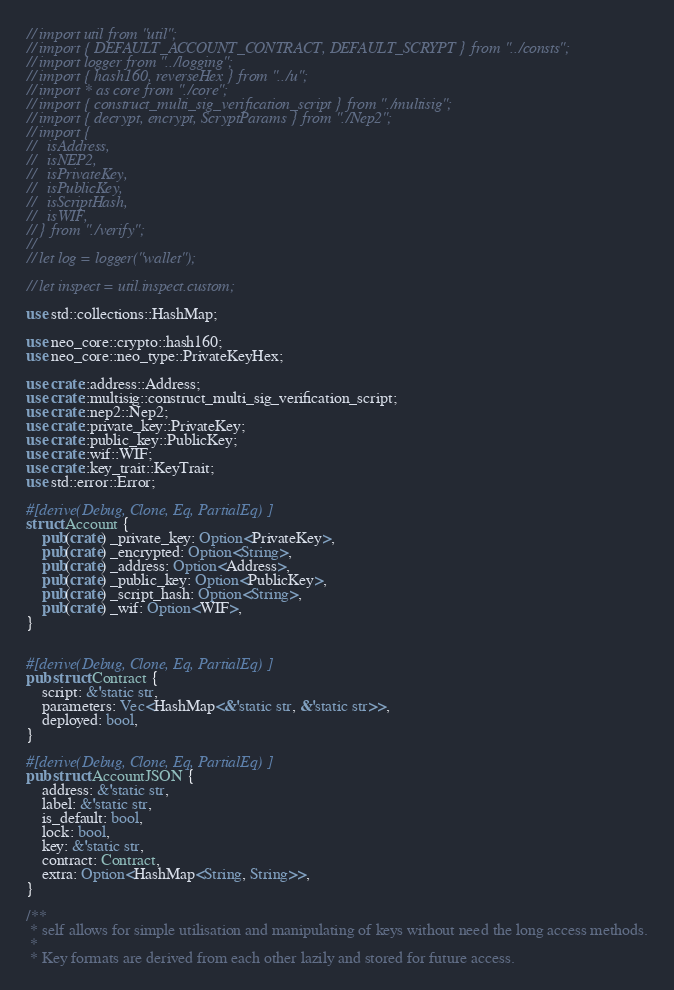<code> <loc_0><loc_0><loc_500><loc_500><_Rust_>// import util from "util";
// import { DEFAULT_ACCOUNT_CONTRACT, DEFAULT_SCRYPT } from "../consts";
// import logger from "../logging";
// import { hash160, reverseHex } from "../u";
// import * as core from "./core";
// import { construct_multi_sig_verification_script } from "./multisig";
// import { decrypt, encrypt, ScryptParams } from "./Nep2";
// import {
//   isAddress,
//   isNEP2,
//   isPrivateKey,
//   isPublicKey,
//   isScriptHash,
//   isWIF,
// } from "./verify";
//
// let log = logger("wallet");

// let inspect = util.inspect.custom;

use std::collections::HashMap;

use neo_core::crypto::hash160;
use neo_core::neo_type::PrivateKeyHex;

use crate::address::Address;
use crate::multisig::construct_multi_sig_verification_script;
use crate::nep2::Nep2;
use crate::private_key::PrivateKey;
use crate::public_key::PublicKey;
use crate::wif::WIF;
use crate::key_trait::KeyTrait;
use std::error::Error;

#[derive(Debug, Clone, Eq, PartialEq)]
struct Account {
    pub(crate) _private_key: Option<PrivateKey>,
    pub(crate) _encrypted: Option<String>,
    pub(crate) _address: Option<Address>,
    pub(crate) _public_key: Option<PublicKey>,
    pub(crate) _script_hash: Option<String>,
    pub(crate) _wif: Option<WIF>,
}


#[derive(Debug, Clone, Eq, PartialEq)]
pub struct Contract {
    script: &'static str,
    parameters: Vec<HashMap<&'static str, &'static str>>,
    deployed: bool,
}

#[derive(Debug, Clone, Eq, PartialEq)]
pub struct AccountJSON {
    address: &'static str,
    label: &'static str,
    is_default: bool,
    lock: bool,
    key: &'static str,
    contract: Contract,
    extra: Option<HashMap<String, String>>,
}

/**
 * self allows for simple utilisation and manipulating of keys without need the long access methods.
 *
 * Key formats are derived from each other lazily and stored for future access.</code> 